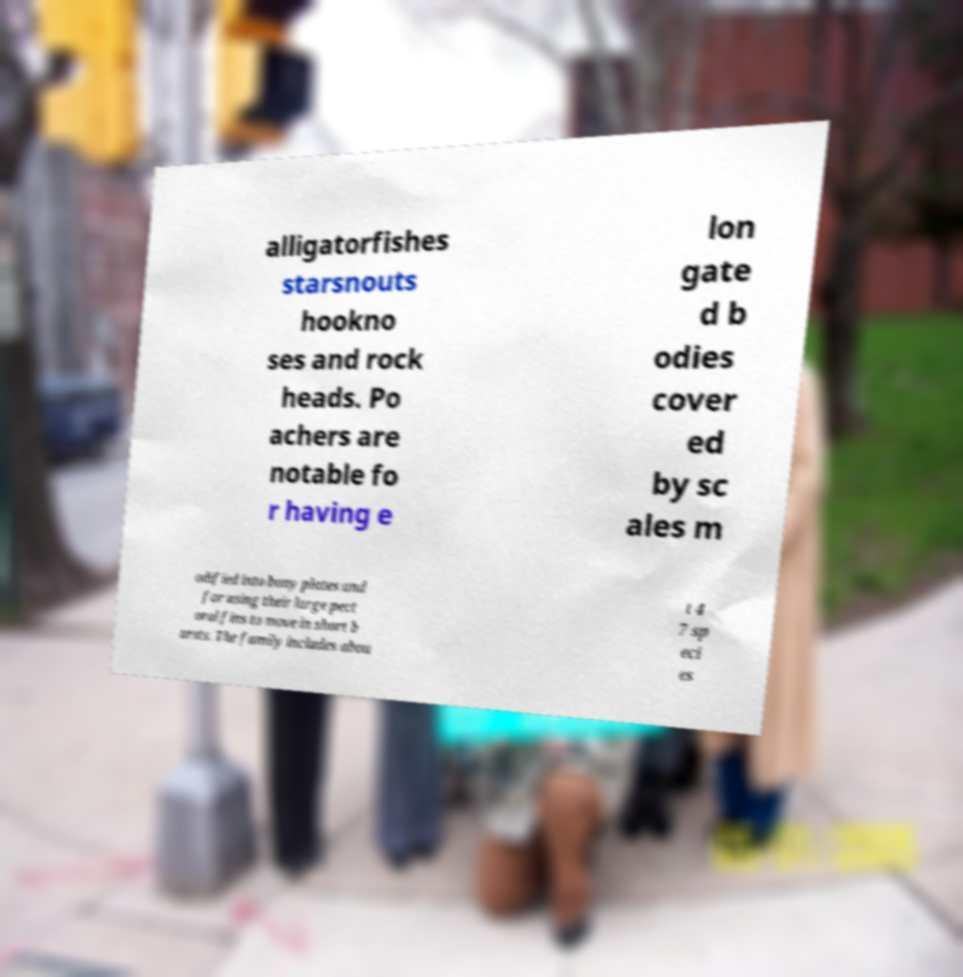Could you assist in decoding the text presented in this image and type it out clearly? alligatorfishes starsnouts hookno ses and rock heads. Po achers are notable fo r having e lon gate d b odies cover ed by sc ales m odified into bony plates and for using their large pect oral fins to move in short b ursts. The family includes abou t 4 7 sp eci es 